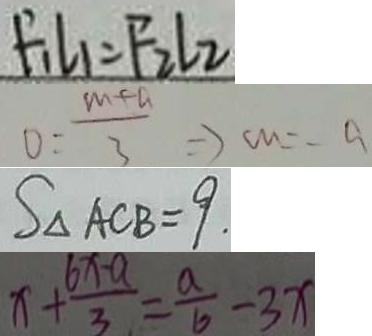Convert formula to latex. <formula><loc_0><loc_0><loc_500><loc_500>F _ { 1 } l _ { 1 } = F _ { 2 } l _ { 2 } 
 O = \frac { m + a } { 3 } \Rightarrow c m = - a 
 S _ { \Delta } A C B = 9 . 
 x + \frac { 6 x - a } { 3 } = \frac { a } { b } - 3 x</formula> 